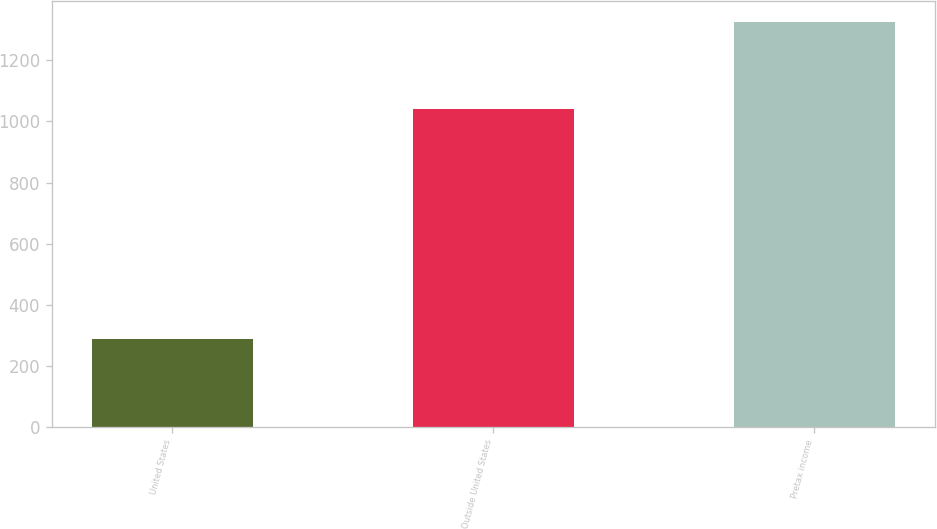Convert chart to OTSL. <chart><loc_0><loc_0><loc_500><loc_500><bar_chart><fcel>United States<fcel>Outside United States<fcel>Pretax income<nl><fcel>286<fcel>1041<fcel>1327<nl></chart> 